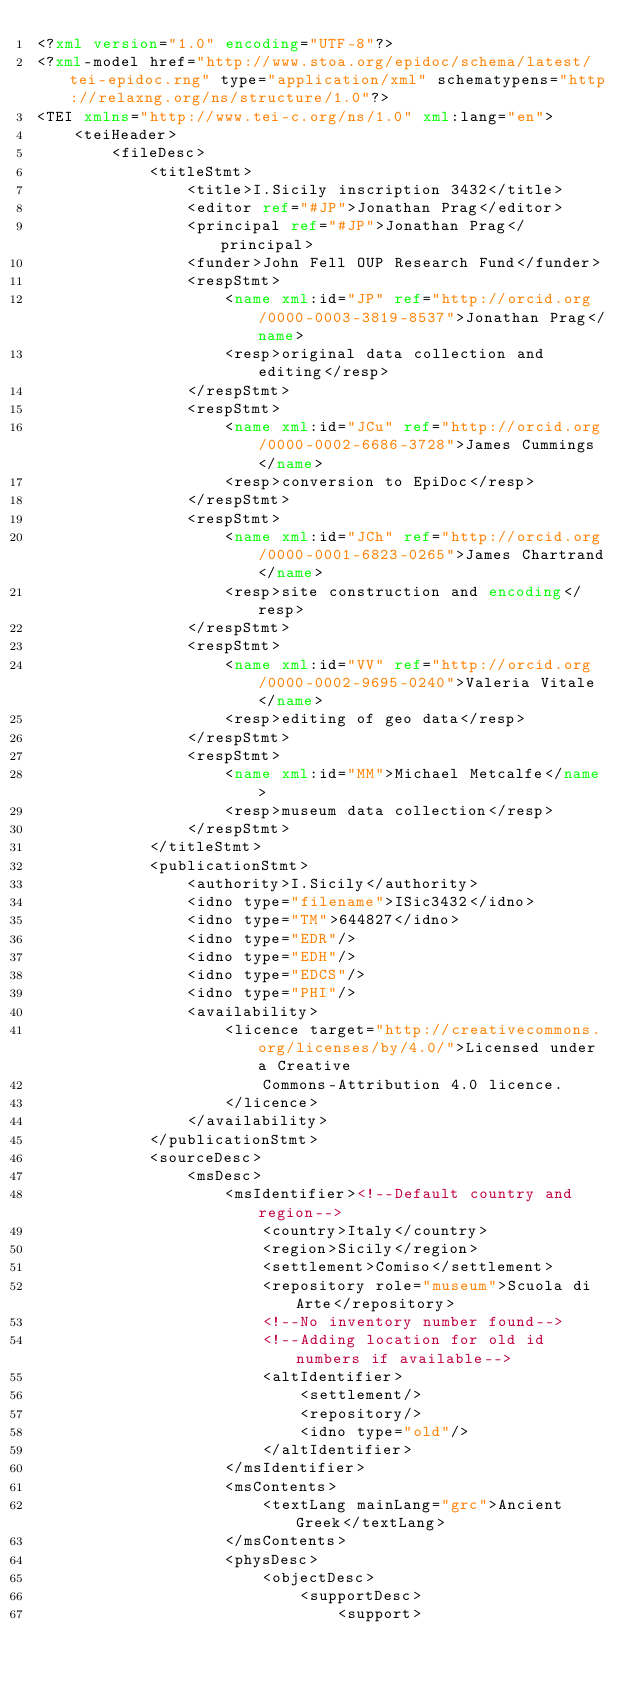<code> <loc_0><loc_0><loc_500><loc_500><_XML_><?xml version="1.0" encoding="UTF-8"?>
<?xml-model href="http://www.stoa.org/epidoc/schema/latest/tei-epidoc.rng" type="application/xml" schematypens="http://relaxng.org/ns/structure/1.0"?>
<TEI xmlns="http://www.tei-c.org/ns/1.0" xml:lang="en">
    <teiHeader>
        <fileDesc>
            <titleStmt>
                <title>I.Sicily inscription 3432</title>
                <editor ref="#JP">Jonathan Prag</editor>
                <principal ref="#JP">Jonathan Prag</principal>
                <funder>John Fell OUP Research Fund</funder>
                <respStmt>
                    <name xml:id="JP" ref="http://orcid.org/0000-0003-3819-8537">Jonathan Prag</name>
                    <resp>original data collection and editing</resp>
                </respStmt>
                <respStmt>
                    <name xml:id="JCu" ref="http://orcid.org/0000-0002-6686-3728">James Cummings</name>
                    <resp>conversion to EpiDoc</resp>
                </respStmt>
                <respStmt>
                    <name xml:id="JCh" ref="http://orcid.org/0000-0001-6823-0265">James Chartrand</name>
                    <resp>site construction and encoding</resp>
                </respStmt>
                <respStmt>
                    <name xml:id="VV" ref="http://orcid.org/0000-0002-9695-0240">Valeria Vitale</name>
                    <resp>editing of geo data</resp>
                </respStmt>
                <respStmt>
                    <name xml:id="MM">Michael Metcalfe</name>
                    <resp>museum data collection</resp>
                </respStmt>
            </titleStmt>
            <publicationStmt>
                <authority>I.Sicily</authority>
                <idno type="filename">ISic3432</idno>
                <idno type="TM">644827</idno>
                <idno type="EDR"/>
                <idno type="EDH"/>
                <idno type="EDCS"/>
                <idno type="PHI"/>
                <availability>
                    <licence target="http://creativecommons.org/licenses/by/4.0/">Licensed under a Creative
                        Commons-Attribution 4.0 licence.
                    </licence>
                </availability>
            </publicationStmt>
            <sourceDesc>
                <msDesc>
                    <msIdentifier><!--Default country and region-->
                        <country>Italy</country>
                        <region>Sicily</region>
                        <settlement>Comiso</settlement>
                        <repository role="museum">Scuola di Arte</repository>
                        <!--No inventory number found-->
                        <!--Adding location for old id numbers if available-->
                        <altIdentifier>
                            <settlement/>
                            <repository/>
                            <idno type="old"/>
                        </altIdentifier>
                    </msIdentifier>
                    <msContents>
                        <textLang mainLang="grc">Ancient Greek</textLang>
                    </msContents>
                    <physDesc>
                        <objectDesc>
                            <supportDesc>
                                <support></code> 